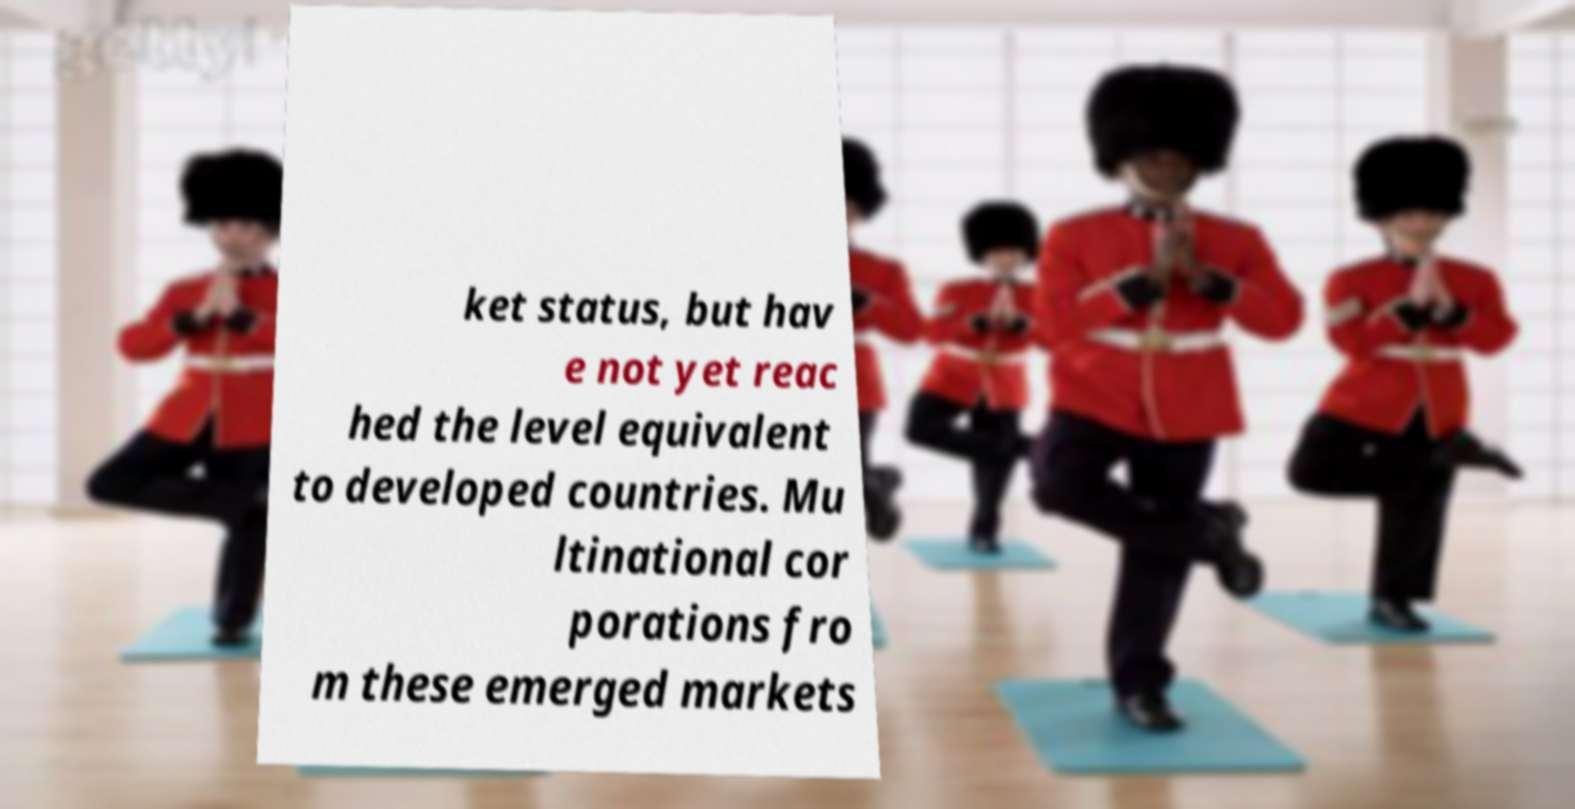Could you extract and type out the text from this image? ket status, but hav e not yet reac hed the level equivalent to developed countries. Mu ltinational cor porations fro m these emerged markets 